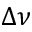<formula> <loc_0><loc_0><loc_500><loc_500>\Delta \nu</formula> 